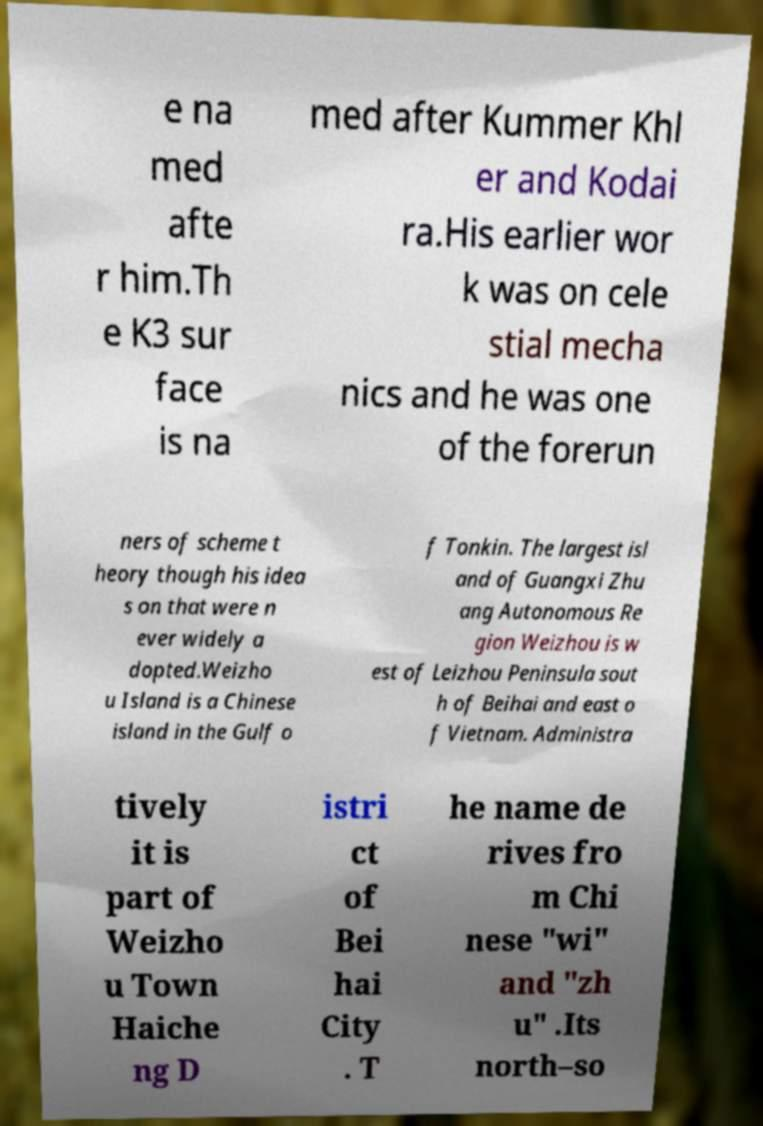Please identify and transcribe the text found in this image. e na med afte r him.Th e K3 sur face is na med after Kummer Khl er and Kodai ra.His earlier wor k was on cele stial mecha nics and he was one of the forerun ners of scheme t heory though his idea s on that were n ever widely a dopted.Weizho u Island is a Chinese island in the Gulf o f Tonkin. The largest isl and of Guangxi Zhu ang Autonomous Re gion Weizhou is w est of Leizhou Peninsula sout h of Beihai and east o f Vietnam. Administra tively it is part of Weizho u Town Haiche ng D istri ct of Bei hai City . T he name de rives fro m Chi nese "wi" and "zh u" .Its north–so 